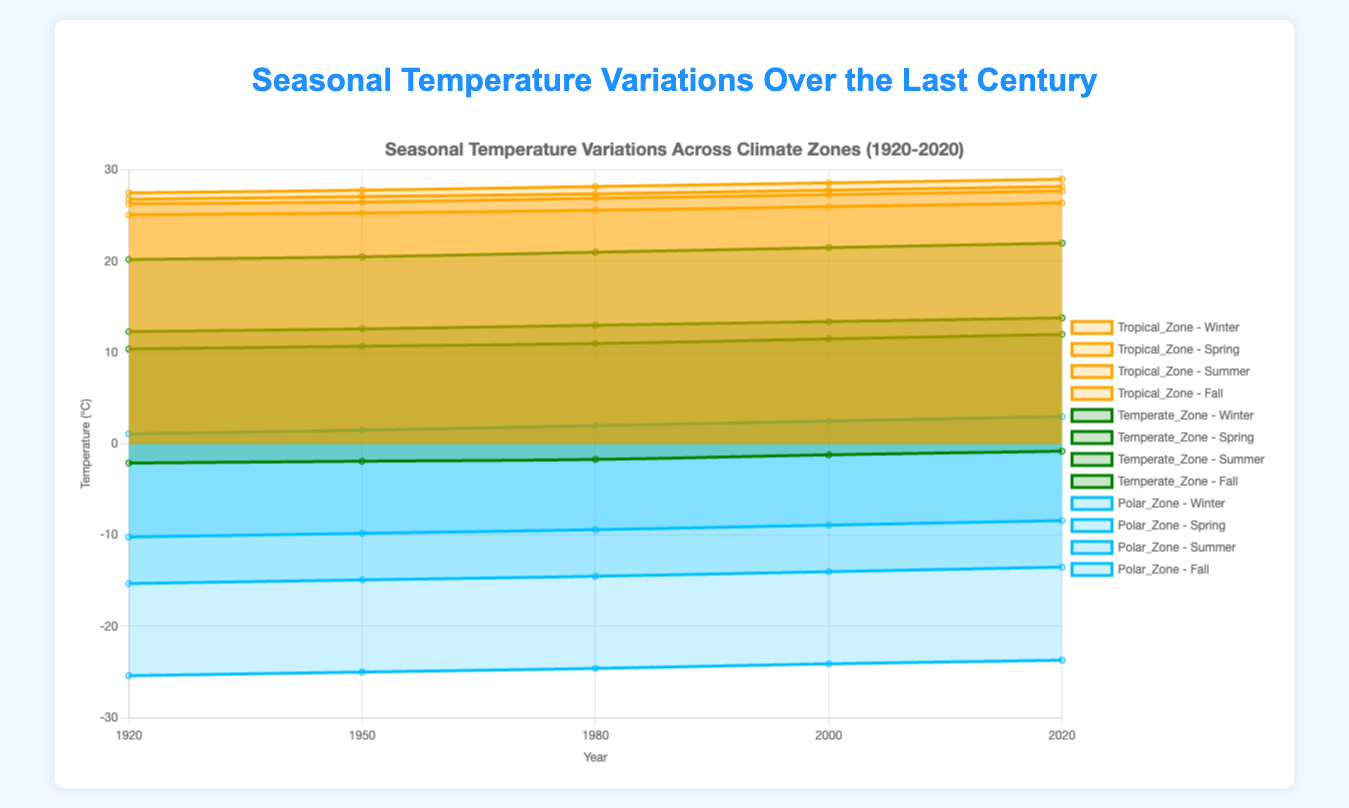Which climate zone displayed the most noticeable increase in summer temperatures from 1920 to 2020? The Tropical Zone showed an increase from 27.5°C in 1920 to 29.0°C in 2020, representing a 1.5°C rise, which is quite significant.
Answer: Tropical Zone What was the trend in the Temperate Zone winter temperatures over the last century? In 1920, the winter temperature was -2.1°C, and progressively increased in subsequent years (-1.9°C in 1950, -1.7°C in 1980, -1.2°C in 2000), reaching -0.8°C in 2020, showing a consistent warming trend.
Answer: Increasing Which season experienced the largest temperature change in the Polar Zone from 1920 to 2020? Winter temperatures in the Polar Zone increased from -25.4°C in 1920 to -23.7°C in 2020, showing the most significant change of 1.7°C. By calculating the changes for other seasons, none exceed this.
Answer: Winter How does the 2020 Spring temperature in the Tropical Zone compare to its Summer temperature? In 2020, the Spring temperature in the Tropical Zone was 27.7°C, while the Summer temperature was 29.0°C, showing that the Summer temperature was higher by 1.3°C.
Answer: Summer is 1.3°C higher What patterns can be observed in the Fall temperatures of the Temperate Zone over the century? Fall temperatures increased from 12.3°C in 1920 to 13.8°C in 2020. The data points show a consistent warming trend over the years, indicating gradual climate change effects.
Answer: Gradual increase Between the Polar Zone and Tropical Zone, which had a greater range of temperature in 2020? In 2020, the Polar Zone temperatures ranged from -23.7°C (Winter) to 3.0°C (Summer), a range of 26.7°C. The Tropical Zone ranged from 26.4°C (Winter) to 29.0°C (Summer), a range of 2.6°C.
Answer: Polar Zone What is the difference in summer temperatures between 2000 and 2020 in the Temperate Zone? Summer temperatures increased from 21.5°C in 2000 to 22.0°C in 2020. Subtracting, we get a difference of 0.5°C, showing slight warming.
Answer: 0.5°C How did winter temperatures change in each climate zone from 1920 to 2020? Tropical Zone increased from 25.1°C to 26.4°C, Temperate Zone went from -2.1°C to -0.8°C, and Polar Zone rose from -25.4°C to -23.7°C. Hence, all zones experienced warming in winter.
Answer: Increased in all zones 